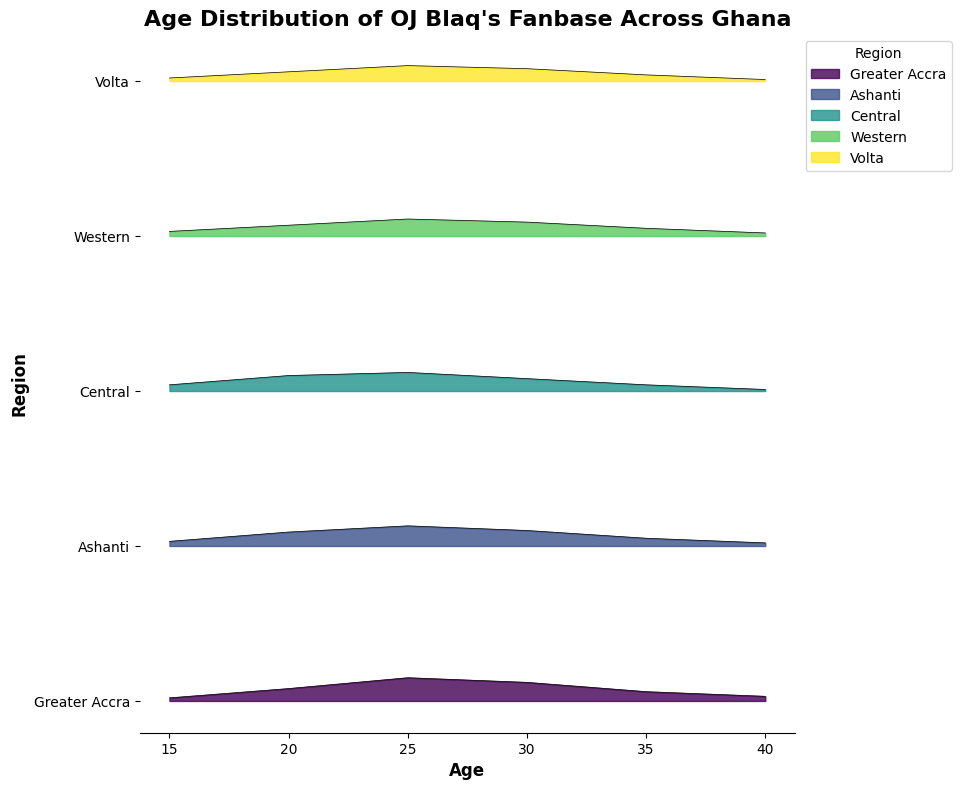What's the title of the figure? The title is located at the top of the figure, usually in a larger and bold font. It provides a summary of what the figure is about. The title here is "Age Distribution of OJ Blaq's Fanbase Across Ghana".
Answer: Age Distribution of OJ Blaq's Fanbase Across Ghana Which region has the highest density at age 25? Identify the curves at age 25 for each region and compare their heights. The region with the tallest curve at this point indicates the highest density. The Greater Accra region has the highest density at age 25 with a density of 0.15.
Answer: Greater Accra At what age does the Western region show the highest density? Look for the peak density value along the age axis for the Western region's curve. The highest peak indicates the age with the highest density. For the Western region, the highest density is at age 25 with a density of 0.11.
Answer: 25 Compare the density at age 20 between Ashanti and Volta regions. Which region has a higher density? Locate age 20 on the x-axis and compare the heights of the curves for Ashanti and Volta regions. The region with a taller segment at age 20 has the higher density. Ashanti has a density of 0.09, while Volta has a density of 0.06; thus, Ashanti has a higher density.
Answer: Ashanti How does the popularity among fans aged 30 in the Volta region compare to those in the Central region? Compare the densities at age 30 for both the Volta and Central regions by checking their curve heights. Volta region has a density of 0.08, and Central region also has a density of 0.08 at age 30, indicating equal popularity at that age.
Answer: They are equal Which age group has the lowest density in the Greater Accra region? Identify the lowest point on the Greater Accra region's curve and determine the corresponding age. The lowest density is observed at age 15 with a value of 0.02.
Answer: 15 What is the sum of densities for the age groups 20 and 30 in the Central region? Find the density values at ages 20 and 30 in the Central region, then add them together. The density at age 20 is 0.10, and at age 30 is 0.08. The sum is 0.10 + 0.08 = 0.18.
Answer: 0.18 Which region shows a consistently decreasing trend in density from age 15 to age 40? Examine each region's curve from age 15 to 40. The region where the curve continuously slopes downward indicates a decreasing trend. The Western region shows a decreasing trend from 0.03 at age 15 to 0.02 at age 40, without any increase in between.
Answer: Western Among all regions, which one has a peak density matching exactly 0.10 at age 30? Scan the figure to find any region with a curve that peaks at the density of 0.10 at age 30. Both the Ashanti and Volta regions have a density of exactly 0.10 at age 30.
Answer: Ashanti and Volta What is the average density of fans aged 35 across all regions? Identify the densities at age 35 for all regions and compute their average. Greater Accra (0.06), Ashanti (0.05), Central (0.04), Western (0.05), Volta (0.04). The average is (0.06 + 0.05 + 0.04 + 0.05 + 0.04) / 5 = 0.048.
Answer: 0.048 